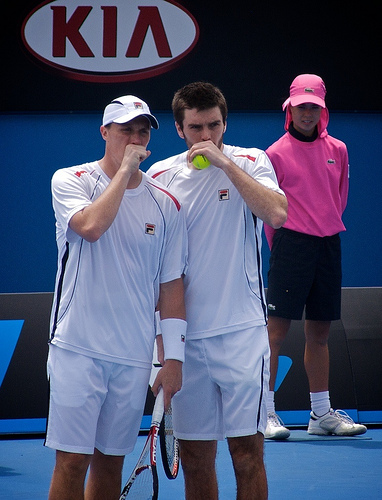Please transcribe the text information in this image. KIA 